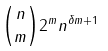Convert formula to latex. <formula><loc_0><loc_0><loc_500><loc_500>\binom { n } { m } 2 ^ { m } n ^ { \delta m + 1 }</formula> 